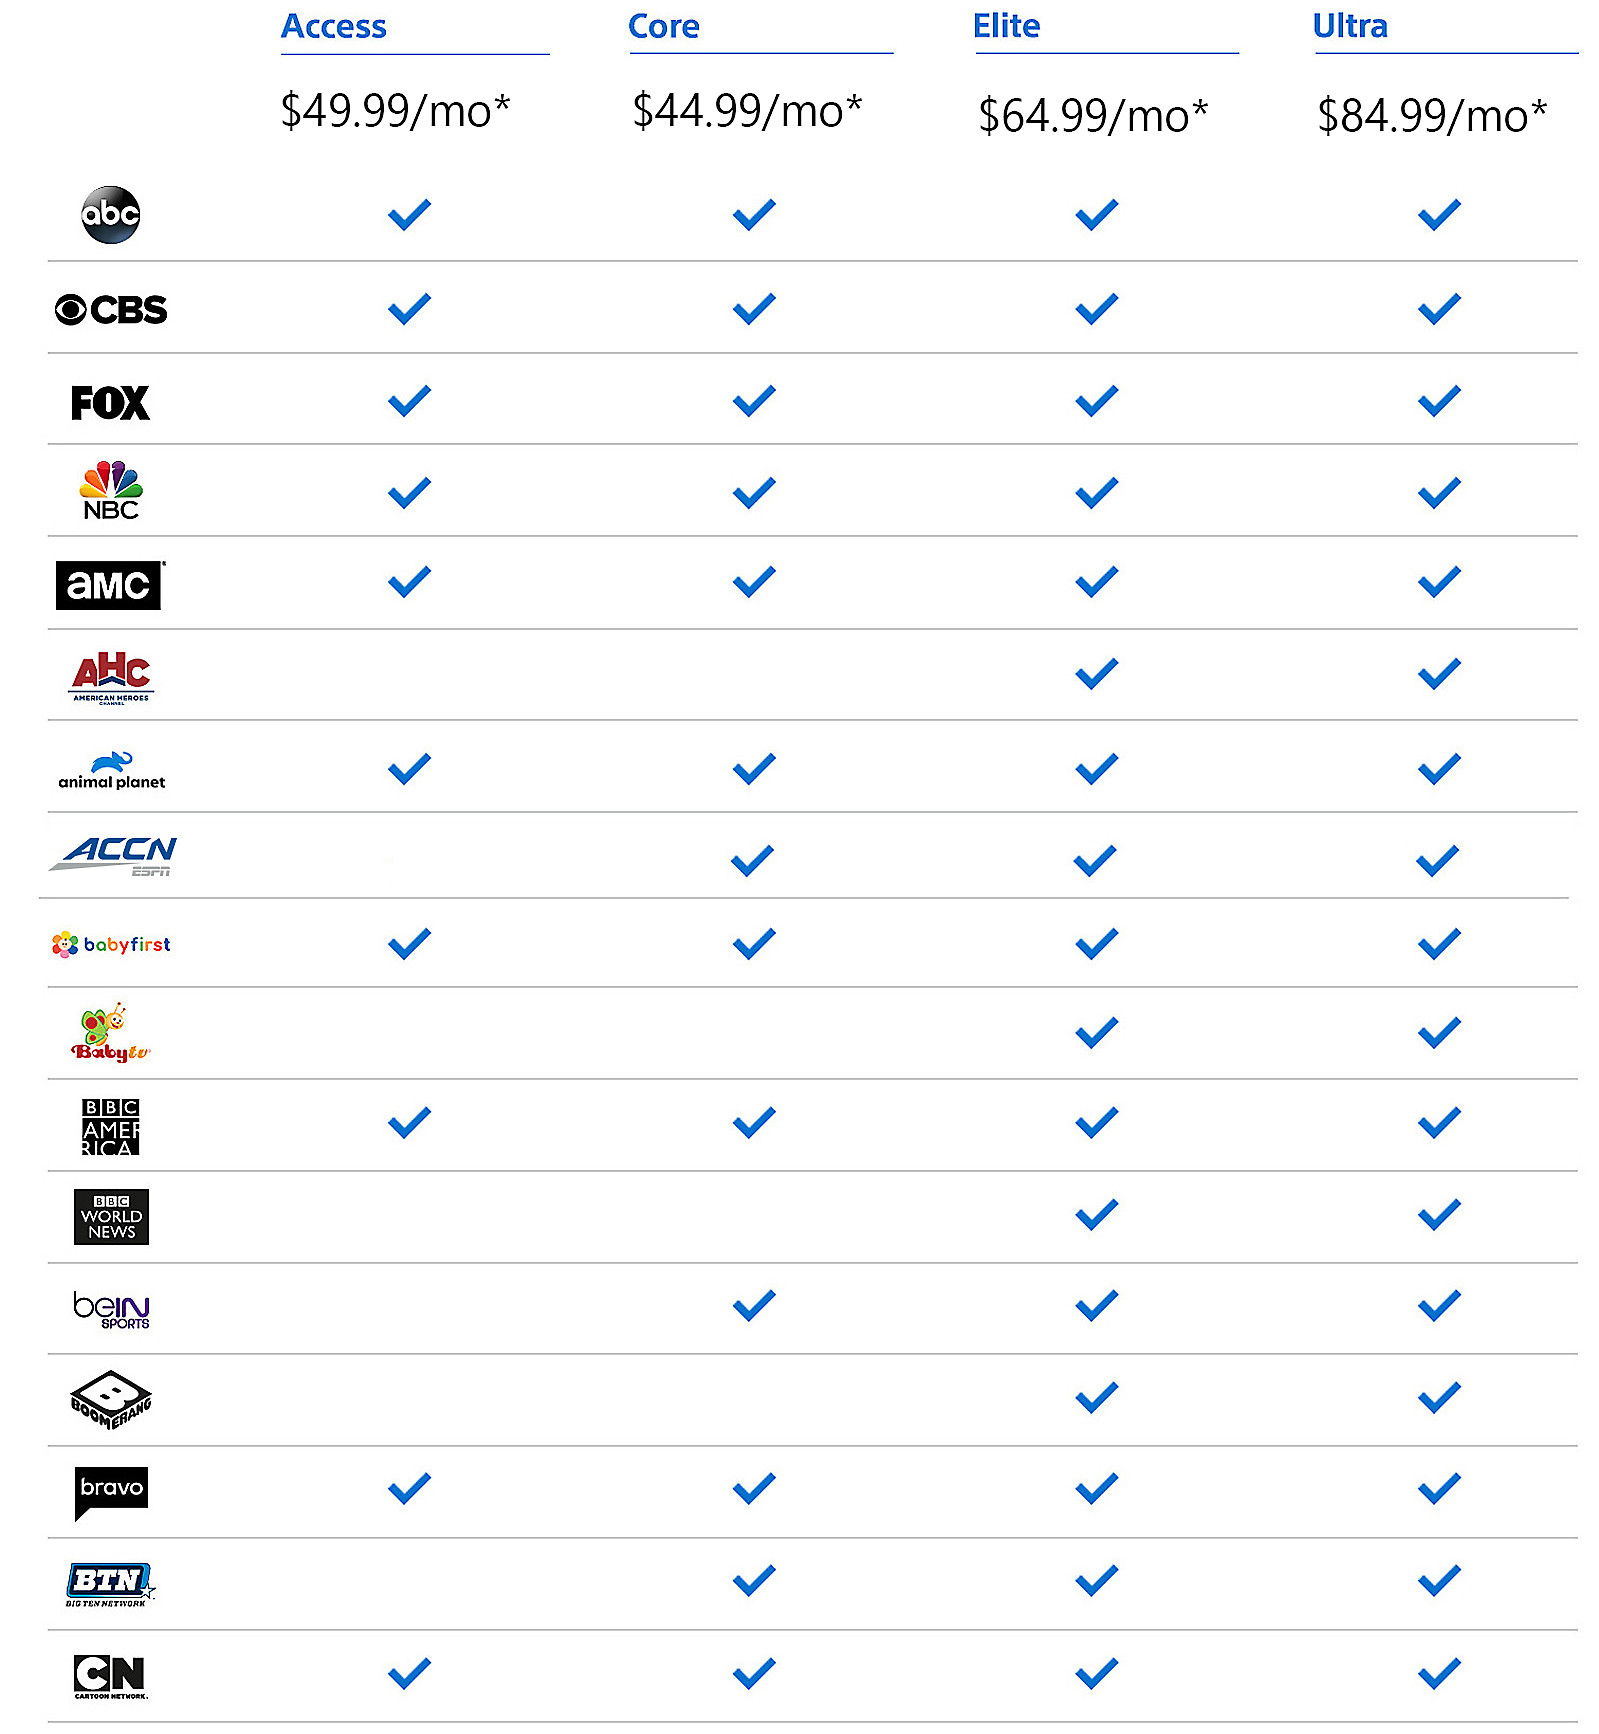Can you highlight key differences between the Core and Elite packages? Certainly! The Core package offers a selection of channels at $44.99/mo, while the Elite package at $64.99/mo includes all the channels in the Core package plus additional channels such as BabyFirst, Bravo, and Boomerang. This upgrade provides access to more family-friendly and lifestyle content, catering to a wider range of interests and audiences. Are there any exclusive channels in the Ultra package? Yes, the Ultra package at $84.99/mo includes all the channels available in the Elite package, along with additional premium channels. This package is ideal for viewers seeking the most comprehensive selection of entertainment, sports, news, and family programming. Which package would you recommend for a sports enthusiast? For a sports enthusiast, I would recommend the Core package or higher. The Core package includes channels like beIN SPORTS and ACCN, which offer extensive sports coverage. However, upgrading to the Elite or Ultra packages would provide an even broader range of sports content, including additional exclusive sports channels. 